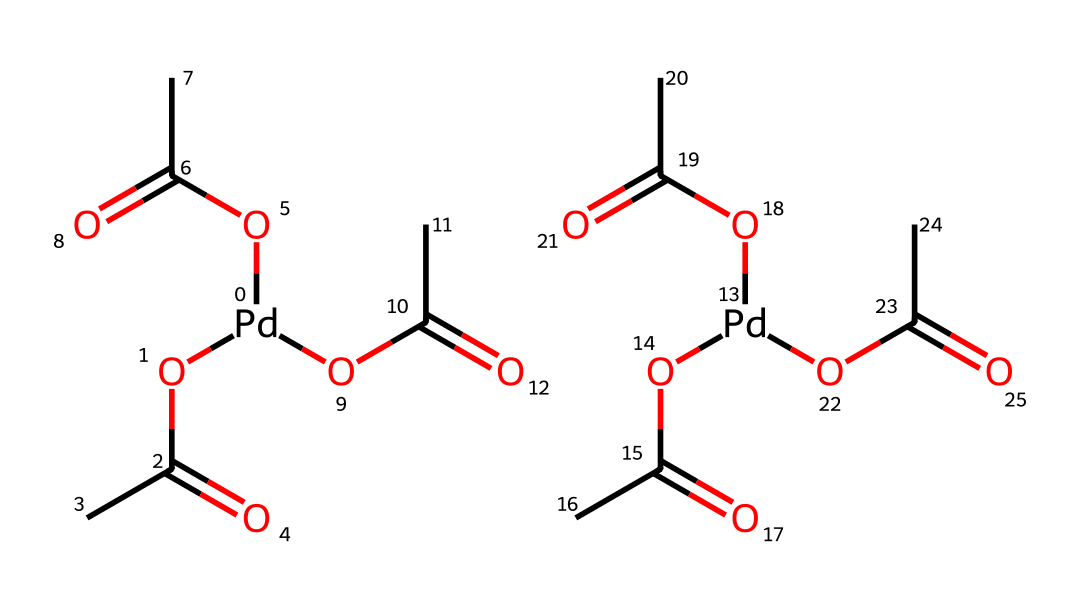How many acetate groups are present in this molecule? The SMILES representation shows three acetate groups (OC(C)=O) attached to the palladium atom. Each acetate group corresponds to one of the OC(C)=O units.
Answer: three What is the oxidation state of the palladium in this compound? Palladium (Pd) typically exhibits oxidation states of +2 or +4 in organometallic compounds. Given that it coordinates with three acetate anions, the oxidation state of palladium in palladium acetate is +2.
Answer: +2 How many total carbon atoms are in this molecule? Each acetate group has two carbon atoms and there are three acetate groups, leading to a total of 3 x 2 = 6 carbon atoms.
Answer: six What type of bonding is present between palladium and acetate? The palladium atom forms coordinate covalent bonds with each of the acetate groups, where the acetate acts as a ligand donating electrons to the metal center.
Answer: coordinate covalent What is the coordination number of palladium in this structure? Palladium is surrounded by three acetate ligands, resulting in a coordination number of 6 due to the octahedral arrangement formed.
Answer: six What is the primary role of palladium acetate in organic synthesis? Palladium acetate acts as a catalyst in cross-coupling reactions, facilitating the formation of carbon-carbon bonds between organic molecules.
Answer: catalyst 